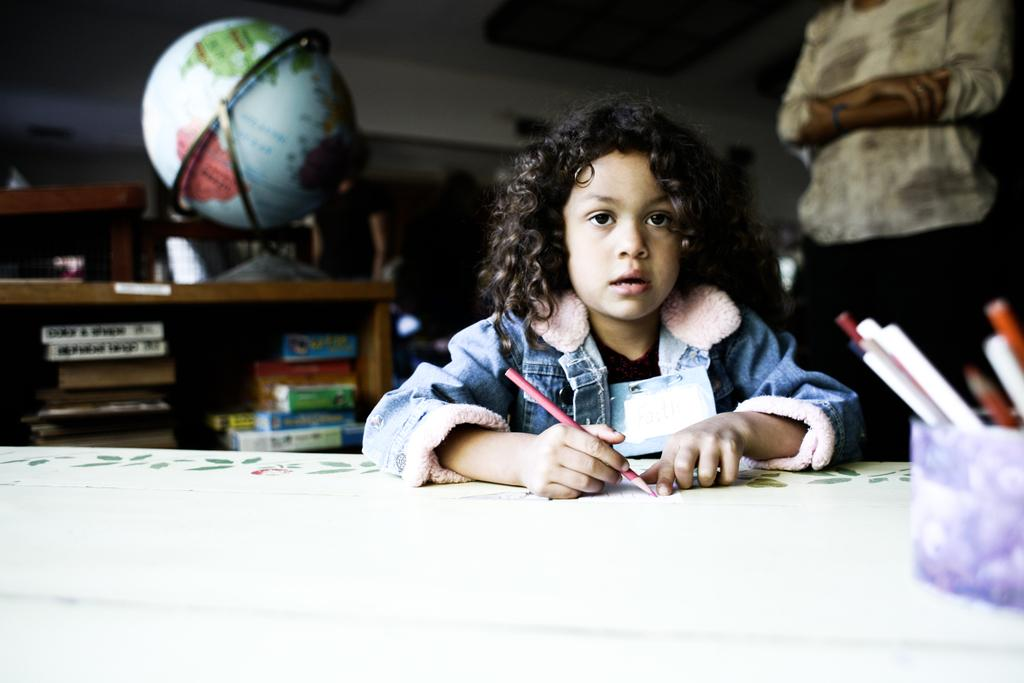What is the main subject of the image? There is a person sitting in the center of the image. What is the person holding in the image? The person is holding a pencil. What can be seen in the background of the image? There is a wall in the background of the image. Are there any other people visible in the image? Yes, there is another person standing in the background of the image. What type of steam is coming from the dinner in the image? There is no dinner or steam present in the image. 